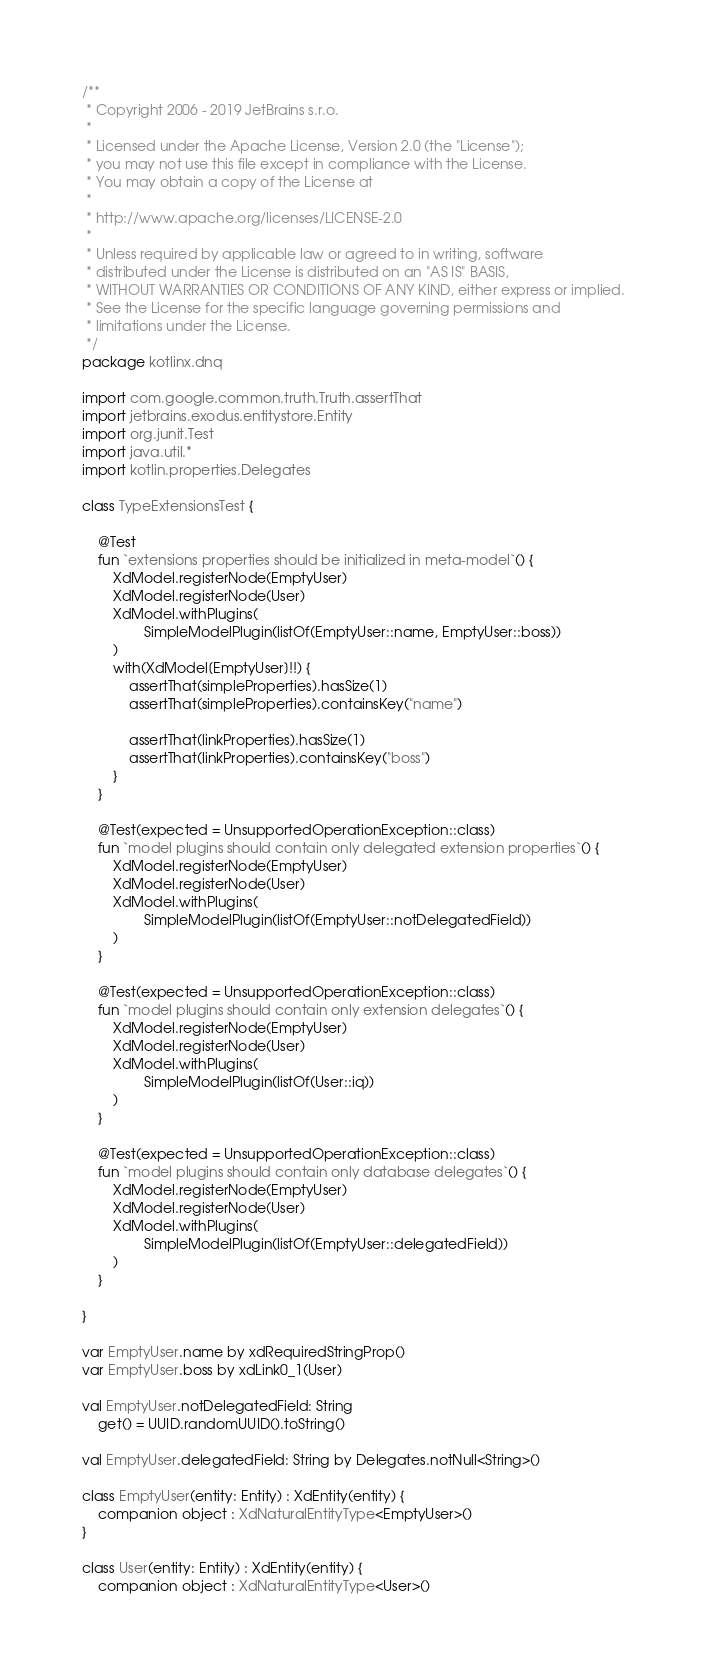Convert code to text. <code><loc_0><loc_0><loc_500><loc_500><_Kotlin_>/**
 * Copyright 2006 - 2019 JetBrains s.r.o.
 *
 * Licensed under the Apache License, Version 2.0 (the "License");
 * you may not use this file except in compliance with the License.
 * You may obtain a copy of the License at
 *
 * http://www.apache.org/licenses/LICENSE-2.0
 *
 * Unless required by applicable law or agreed to in writing, software
 * distributed under the License is distributed on an "AS IS" BASIS,
 * WITHOUT WARRANTIES OR CONDITIONS OF ANY KIND, either express or implied.
 * See the License for the specific language governing permissions and
 * limitations under the License.
 */
package kotlinx.dnq

import com.google.common.truth.Truth.assertThat
import jetbrains.exodus.entitystore.Entity
import org.junit.Test
import java.util.*
import kotlin.properties.Delegates

class TypeExtensionsTest {

    @Test
    fun `extensions properties should be initialized in meta-model`() {
        XdModel.registerNode(EmptyUser)
        XdModel.registerNode(User)
        XdModel.withPlugins(
                SimpleModelPlugin(listOf(EmptyUser::name, EmptyUser::boss))
        )
        with(XdModel[EmptyUser]!!) {
            assertThat(simpleProperties).hasSize(1)
            assertThat(simpleProperties).containsKey("name")

            assertThat(linkProperties).hasSize(1)
            assertThat(linkProperties).containsKey("boss")
        }
    }

    @Test(expected = UnsupportedOperationException::class)
    fun `model plugins should contain only delegated extension properties`() {
        XdModel.registerNode(EmptyUser)
        XdModel.registerNode(User)
        XdModel.withPlugins(
                SimpleModelPlugin(listOf(EmptyUser::notDelegatedField))
        )
    }

    @Test(expected = UnsupportedOperationException::class)
    fun `model plugins should contain only extension delegates`() {
        XdModel.registerNode(EmptyUser)
        XdModel.registerNode(User)
        XdModel.withPlugins(
                SimpleModelPlugin(listOf(User::iq))
        )
    }

    @Test(expected = UnsupportedOperationException::class)
    fun `model plugins should contain only database delegates`() {
        XdModel.registerNode(EmptyUser)
        XdModel.registerNode(User)
        XdModel.withPlugins(
                SimpleModelPlugin(listOf(EmptyUser::delegatedField))
        )
    }

}

var EmptyUser.name by xdRequiredStringProp()
var EmptyUser.boss by xdLink0_1(User)

val EmptyUser.notDelegatedField: String
    get() = UUID.randomUUID().toString()

val EmptyUser.delegatedField: String by Delegates.notNull<String>()

class EmptyUser(entity: Entity) : XdEntity(entity) {
    companion object : XdNaturalEntityType<EmptyUser>()
}

class User(entity: Entity) : XdEntity(entity) {
    companion object : XdNaturalEntityType<User>()
</code> 